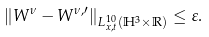Convert formula to latex. <formula><loc_0><loc_0><loc_500><loc_500>\| W ^ { \nu } - W ^ { \nu , \prime } \| _ { L ^ { 1 0 } _ { x , t } ( \mathbb { H } ^ { 3 } \times \mathbb { R } ) } \leq \varepsilon .</formula> 